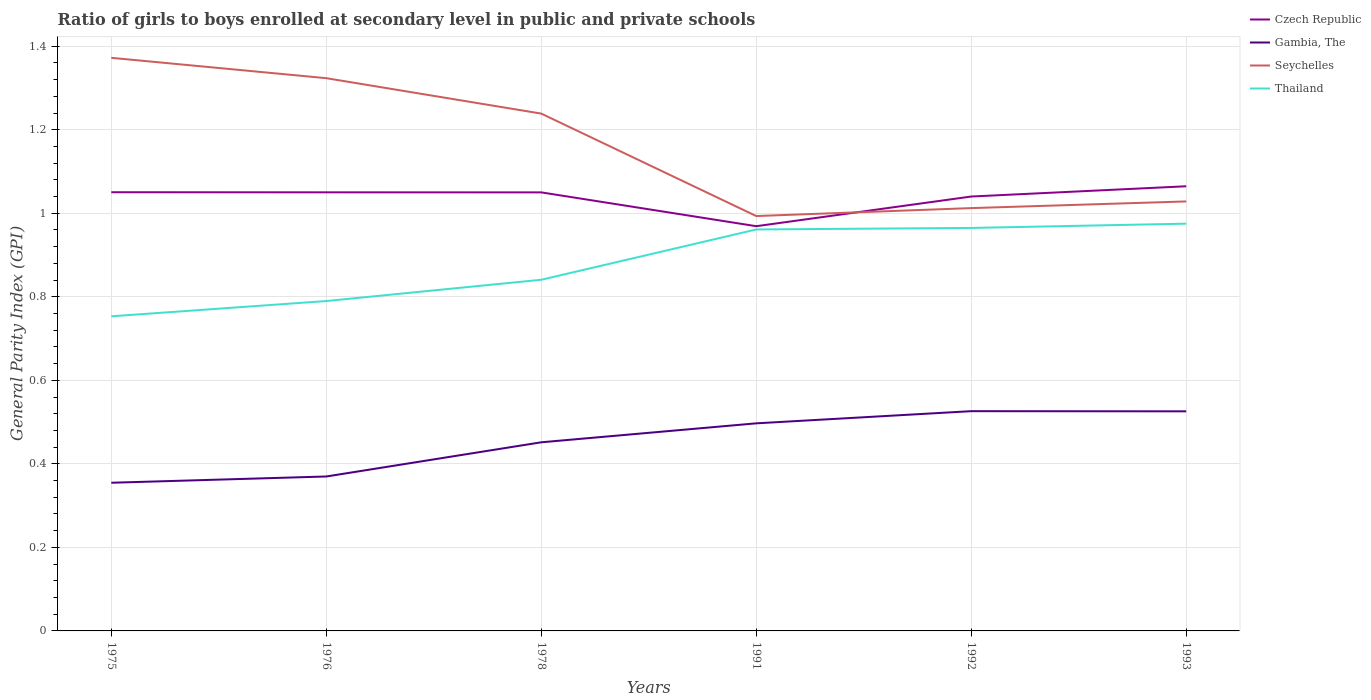How many different coloured lines are there?
Your answer should be very brief. 4. Does the line corresponding to Seychelles intersect with the line corresponding to Thailand?
Your answer should be very brief. No. Is the number of lines equal to the number of legend labels?
Your response must be concise. Yes. Across all years, what is the maximum general parity index in Czech Republic?
Make the answer very short. 0.97. What is the total general parity index in Gambia, The in the graph?
Make the answer very short. -0.1. What is the difference between the highest and the second highest general parity index in Thailand?
Offer a very short reply. 0.22. What is the difference between the highest and the lowest general parity index in Seychelles?
Provide a succinct answer. 3. Is the general parity index in Thailand strictly greater than the general parity index in Seychelles over the years?
Offer a very short reply. Yes. Where does the legend appear in the graph?
Offer a very short reply. Top right. How many legend labels are there?
Your response must be concise. 4. How are the legend labels stacked?
Your response must be concise. Vertical. What is the title of the graph?
Your answer should be very brief. Ratio of girls to boys enrolled at secondary level in public and private schools. Does "Euro area" appear as one of the legend labels in the graph?
Provide a short and direct response. No. What is the label or title of the Y-axis?
Give a very brief answer. General Parity Index (GPI). What is the General Parity Index (GPI) of Czech Republic in 1975?
Offer a very short reply. 1.05. What is the General Parity Index (GPI) in Gambia, The in 1975?
Keep it short and to the point. 0.35. What is the General Parity Index (GPI) in Seychelles in 1975?
Keep it short and to the point. 1.37. What is the General Parity Index (GPI) of Thailand in 1975?
Make the answer very short. 0.75. What is the General Parity Index (GPI) of Czech Republic in 1976?
Offer a terse response. 1.05. What is the General Parity Index (GPI) in Gambia, The in 1976?
Offer a very short reply. 0.37. What is the General Parity Index (GPI) of Seychelles in 1976?
Your answer should be very brief. 1.32. What is the General Parity Index (GPI) of Thailand in 1976?
Your answer should be very brief. 0.79. What is the General Parity Index (GPI) in Czech Republic in 1978?
Your answer should be compact. 1.05. What is the General Parity Index (GPI) of Gambia, The in 1978?
Your response must be concise. 0.45. What is the General Parity Index (GPI) in Seychelles in 1978?
Provide a succinct answer. 1.24. What is the General Parity Index (GPI) of Thailand in 1978?
Keep it short and to the point. 0.84. What is the General Parity Index (GPI) of Czech Republic in 1991?
Offer a terse response. 0.97. What is the General Parity Index (GPI) of Gambia, The in 1991?
Provide a short and direct response. 0.5. What is the General Parity Index (GPI) in Seychelles in 1991?
Offer a very short reply. 0.99. What is the General Parity Index (GPI) in Thailand in 1991?
Keep it short and to the point. 0.96. What is the General Parity Index (GPI) of Czech Republic in 1992?
Ensure brevity in your answer.  1.04. What is the General Parity Index (GPI) in Gambia, The in 1992?
Offer a very short reply. 0.53. What is the General Parity Index (GPI) of Seychelles in 1992?
Provide a short and direct response. 1.01. What is the General Parity Index (GPI) of Thailand in 1992?
Make the answer very short. 0.96. What is the General Parity Index (GPI) in Czech Republic in 1993?
Make the answer very short. 1.06. What is the General Parity Index (GPI) of Gambia, The in 1993?
Make the answer very short. 0.53. What is the General Parity Index (GPI) of Seychelles in 1993?
Provide a short and direct response. 1.03. What is the General Parity Index (GPI) of Thailand in 1993?
Provide a short and direct response. 0.98. Across all years, what is the maximum General Parity Index (GPI) of Czech Republic?
Provide a succinct answer. 1.06. Across all years, what is the maximum General Parity Index (GPI) of Gambia, The?
Provide a short and direct response. 0.53. Across all years, what is the maximum General Parity Index (GPI) of Seychelles?
Your answer should be very brief. 1.37. Across all years, what is the maximum General Parity Index (GPI) in Thailand?
Offer a very short reply. 0.98. Across all years, what is the minimum General Parity Index (GPI) of Czech Republic?
Offer a very short reply. 0.97. Across all years, what is the minimum General Parity Index (GPI) of Gambia, The?
Your response must be concise. 0.35. Across all years, what is the minimum General Parity Index (GPI) of Seychelles?
Provide a succinct answer. 0.99. Across all years, what is the minimum General Parity Index (GPI) of Thailand?
Your response must be concise. 0.75. What is the total General Parity Index (GPI) of Czech Republic in the graph?
Your answer should be compact. 6.22. What is the total General Parity Index (GPI) of Gambia, The in the graph?
Offer a very short reply. 2.73. What is the total General Parity Index (GPI) in Seychelles in the graph?
Make the answer very short. 6.97. What is the total General Parity Index (GPI) of Thailand in the graph?
Ensure brevity in your answer.  5.29. What is the difference between the General Parity Index (GPI) of Gambia, The in 1975 and that in 1976?
Offer a terse response. -0.01. What is the difference between the General Parity Index (GPI) in Seychelles in 1975 and that in 1976?
Provide a short and direct response. 0.05. What is the difference between the General Parity Index (GPI) of Thailand in 1975 and that in 1976?
Provide a succinct answer. -0.04. What is the difference between the General Parity Index (GPI) in Czech Republic in 1975 and that in 1978?
Ensure brevity in your answer.  0. What is the difference between the General Parity Index (GPI) of Gambia, The in 1975 and that in 1978?
Provide a succinct answer. -0.1. What is the difference between the General Parity Index (GPI) of Seychelles in 1975 and that in 1978?
Provide a succinct answer. 0.13. What is the difference between the General Parity Index (GPI) of Thailand in 1975 and that in 1978?
Give a very brief answer. -0.09. What is the difference between the General Parity Index (GPI) in Czech Republic in 1975 and that in 1991?
Your answer should be compact. 0.08. What is the difference between the General Parity Index (GPI) in Gambia, The in 1975 and that in 1991?
Give a very brief answer. -0.14. What is the difference between the General Parity Index (GPI) of Seychelles in 1975 and that in 1991?
Keep it short and to the point. 0.38. What is the difference between the General Parity Index (GPI) of Thailand in 1975 and that in 1991?
Your response must be concise. -0.21. What is the difference between the General Parity Index (GPI) in Czech Republic in 1975 and that in 1992?
Your answer should be compact. 0.01. What is the difference between the General Parity Index (GPI) of Gambia, The in 1975 and that in 1992?
Your answer should be very brief. -0.17. What is the difference between the General Parity Index (GPI) of Seychelles in 1975 and that in 1992?
Give a very brief answer. 0.36. What is the difference between the General Parity Index (GPI) in Thailand in 1975 and that in 1992?
Give a very brief answer. -0.21. What is the difference between the General Parity Index (GPI) in Czech Republic in 1975 and that in 1993?
Your answer should be very brief. -0.01. What is the difference between the General Parity Index (GPI) of Gambia, The in 1975 and that in 1993?
Your response must be concise. -0.17. What is the difference between the General Parity Index (GPI) of Seychelles in 1975 and that in 1993?
Keep it short and to the point. 0.34. What is the difference between the General Parity Index (GPI) of Thailand in 1975 and that in 1993?
Keep it short and to the point. -0.22. What is the difference between the General Parity Index (GPI) in Gambia, The in 1976 and that in 1978?
Provide a succinct answer. -0.08. What is the difference between the General Parity Index (GPI) in Seychelles in 1976 and that in 1978?
Make the answer very short. 0.08. What is the difference between the General Parity Index (GPI) of Thailand in 1976 and that in 1978?
Keep it short and to the point. -0.05. What is the difference between the General Parity Index (GPI) in Czech Republic in 1976 and that in 1991?
Give a very brief answer. 0.08. What is the difference between the General Parity Index (GPI) in Gambia, The in 1976 and that in 1991?
Your answer should be very brief. -0.13. What is the difference between the General Parity Index (GPI) in Seychelles in 1976 and that in 1991?
Ensure brevity in your answer.  0.33. What is the difference between the General Parity Index (GPI) in Thailand in 1976 and that in 1991?
Your answer should be compact. -0.17. What is the difference between the General Parity Index (GPI) in Czech Republic in 1976 and that in 1992?
Your answer should be compact. 0.01. What is the difference between the General Parity Index (GPI) in Gambia, The in 1976 and that in 1992?
Your response must be concise. -0.16. What is the difference between the General Parity Index (GPI) of Seychelles in 1976 and that in 1992?
Provide a succinct answer. 0.31. What is the difference between the General Parity Index (GPI) of Thailand in 1976 and that in 1992?
Provide a short and direct response. -0.17. What is the difference between the General Parity Index (GPI) in Czech Republic in 1976 and that in 1993?
Provide a succinct answer. -0.01. What is the difference between the General Parity Index (GPI) in Gambia, The in 1976 and that in 1993?
Offer a very short reply. -0.16. What is the difference between the General Parity Index (GPI) in Seychelles in 1976 and that in 1993?
Give a very brief answer. 0.3. What is the difference between the General Parity Index (GPI) in Thailand in 1976 and that in 1993?
Offer a very short reply. -0.19. What is the difference between the General Parity Index (GPI) in Czech Republic in 1978 and that in 1991?
Your answer should be compact. 0.08. What is the difference between the General Parity Index (GPI) in Gambia, The in 1978 and that in 1991?
Provide a short and direct response. -0.05. What is the difference between the General Parity Index (GPI) in Seychelles in 1978 and that in 1991?
Offer a terse response. 0.25. What is the difference between the General Parity Index (GPI) in Thailand in 1978 and that in 1991?
Offer a very short reply. -0.12. What is the difference between the General Parity Index (GPI) in Czech Republic in 1978 and that in 1992?
Offer a very short reply. 0.01. What is the difference between the General Parity Index (GPI) in Gambia, The in 1978 and that in 1992?
Offer a terse response. -0.07. What is the difference between the General Parity Index (GPI) of Seychelles in 1978 and that in 1992?
Make the answer very short. 0.23. What is the difference between the General Parity Index (GPI) in Thailand in 1978 and that in 1992?
Make the answer very short. -0.12. What is the difference between the General Parity Index (GPI) of Czech Republic in 1978 and that in 1993?
Your answer should be very brief. -0.01. What is the difference between the General Parity Index (GPI) in Gambia, The in 1978 and that in 1993?
Your answer should be very brief. -0.07. What is the difference between the General Parity Index (GPI) in Seychelles in 1978 and that in 1993?
Offer a very short reply. 0.21. What is the difference between the General Parity Index (GPI) in Thailand in 1978 and that in 1993?
Your response must be concise. -0.13. What is the difference between the General Parity Index (GPI) of Czech Republic in 1991 and that in 1992?
Your response must be concise. -0.07. What is the difference between the General Parity Index (GPI) of Gambia, The in 1991 and that in 1992?
Your answer should be very brief. -0.03. What is the difference between the General Parity Index (GPI) in Seychelles in 1991 and that in 1992?
Offer a terse response. -0.02. What is the difference between the General Parity Index (GPI) of Thailand in 1991 and that in 1992?
Give a very brief answer. -0. What is the difference between the General Parity Index (GPI) of Czech Republic in 1991 and that in 1993?
Make the answer very short. -0.1. What is the difference between the General Parity Index (GPI) of Gambia, The in 1991 and that in 1993?
Offer a very short reply. -0.03. What is the difference between the General Parity Index (GPI) in Seychelles in 1991 and that in 1993?
Offer a terse response. -0.04. What is the difference between the General Parity Index (GPI) of Thailand in 1991 and that in 1993?
Offer a terse response. -0.01. What is the difference between the General Parity Index (GPI) in Czech Republic in 1992 and that in 1993?
Your answer should be compact. -0.02. What is the difference between the General Parity Index (GPI) in Seychelles in 1992 and that in 1993?
Offer a very short reply. -0.02. What is the difference between the General Parity Index (GPI) of Thailand in 1992 and that in 1993?
Offer a terse response. -0.01. What is the difference between the General Parity Index (GPI) in Czech Republic in 1975 and the General Parity Index (GPI) in Gambia, The in 1976?
Your answer should be compact. 0.68. What is the difference between the General Parity Index (GPI) in Czech Republic in 1975 and the General Parity Index (GPI) in Seychelles in 1976?
Your answer should be compact. -0.27. What is the difference between the General Parity Index (GPI) of Czech Republic in 1975 and the General Parity Index (GPI) of Thailand in 1976?
Your answer should be compact. 0.26. What is the difference between the General Parity Index (GPI) of Gambia, The in 1975 and the General Parity Index (GPI) of Seychelles in 1976?
Make the answer very short. -0.97. What is the difference between the General Parity Index (GPI) in Gambia, The in 1975 and the General Parity Index (GPI) in Thailand in 1976?
Your answer should be compact. -0.44. What is the difference between the General Parity Index (GPI) of Seychelles in 1975 and the General Parity Index (GPI) of Thailand in 1976?
Provide a succinct answer. 0.58. What is the difference between the General Parity Index (GPI) of Czech Republic in 1975 and the General Parity Index (GPI) of Gambia, The in 1978?
Your response must be concise. 0.6. What is the difference between the General Parity Index (GPI) of Czech Republic in 1975 and the General Parity Index (GPI) of Seychelles in 1978?
Make the answer very short. -0.19. What is the difference between the General Parity Index (GPI) of Czech Republic in 1975 and the General Parity Index (GPI) of Thailand in 1978?
Provide a short and direct response. 0.21. What is the difference between the General Parity Index (GPI) of Gambia, The in 1975 and the General Parity Index (GPI) of Seychelles in 1978?
Offer a very short reply. -0.88. What is the difference between the General Parity Index (GPI) of Gambia, The in 1975 and the General Parity Index (GPI) of Thailand in 1978?
Your response must be concise. -0.49. What is the difference between the General Parity Index (GPI) in Seychelles in 1975 and the General Parity Index (GPI) in Thailand in 1978?
Offer a very short reply. 0.53. What is the difference between the General Parity Index (GPI) of Czech Republic in 1975 and the General Parity Index (GPI) of Gambia, The in 1991?
Your response must be concise. 0.55. What is the difference between the General Parity Index (GPI) of Czech Republic in 1975 and the General Parity Index (GPI) of Seychelles in 1991?
Provide a short and direct response. 0.06. What is the difference between the General Parity Index (GPI) in Czech Republic in 1975 and the General Parity Index (GPI) in Thailand in 1991?
Make the answer very short. 0.09. What is the difference between the General Parity Index (GPI) of Gambia, The in 1975 and the General Parity Index (GPI) of Seychelles in 1991?
Give a very brief answer. -0.64. What is the difference between the General Parity Index (GPI) in Gambia, The in 1975 and the General Parity Index (GPI) in Thailand in 1991?
Offer a terse response. -0.61. What is the difference between the General Parity Index (GPI) of Seychelles in 1975 and the General Parity Index (GPI) of Thailand in 1991?
Provide a short and direct response. 0.41. What is the difference between the General Parity Index (GPI) of Czech Republic in 1975 and the General Parity Index (GPI) of Gambia, The in 1992?
Keep it short and to the point. 0.52. What is the difference between the General Parity Index (GPI) in Czech Republic in 1975 and the General Parity Index (GPI) in Seychelles in 1992?
Your response must be concise. 0.04. What is the difference between the General Parity Index (GPI) of Czech Republic in 1975 and the General Parity Index (GPI) of Thailand in 1992?
Your response must be concise. 0.09. What is the difference between the General Parity Index (GPI) of Gambia, The in 1975 and the General Parity Index (GPI) of Seychelles in 1992?
Make the answer very short. -0.66. What is the difference between the General Parity Index (GPI) in Gambia, The in 1975 and the General Parity Index (GPI) in Thailand in 1992?
Provide a succinct answer. -0.61. What is the difference between the General Parity Index (GPI) in Seychelles in 1975 and the General Parity Index (GPI) in Thailand in 1992?
Your answer should be very brief. 0.41. What is the difference between the General Parity Index (GPI) in Czech Republic in 1975 and the General Parity Index (GPI) in Gambia, The in 1993?
Provide a succinct answer. 0.52. What is the difference between the General Parity Index (GPI) in Czech Republic in 1975 and the General Parity Index (GPI) in Seychelles in 1993?
Offer a very short reply. 0.02. What is the difference between the General Parity Index (GPI) of Czech Republic in 1975 and the General Parity Index (GPI) of Thailand in 1993?
Give a very brief answer. 0.08. What is the difference between the General Parity Index (GPI) in Gambia, The in 1975 and the General Parity Index (GPI) in Seychelles in 1993?
Provide a short and direct response. -0.67. What is the difference between the General Parity Index (GPI) in Gambia, The in 1975 and the General Parity Index (GPI) in Thailand in 1993?
Make the answer very short. -0.62. What is the difference between the General Parity Index (GPI) of Seychelles in 1975 and the General Parity Index (GPI) of Thailand in 1993?
Offer a terse response. 0.4. What is the difference between the General Parity Index (GPI) in Czech Republic in 1976 and the General Parity Index (GPI) in Gambia, The in 1978?
Provide a short and direct response. 0.6. What is the difference between the General Parity Index (GPI) of Czech Republic in 1976 and the General Parity Index (GPI) of Seychelles in 1978?
Offer a terse response. -0.19. What is the difference between the General Parity Index (GPI) of Czech Republic in 1976 and the General Parity Index (GPI) of Thailand in 1978?
Keep it short and to the point. 0.21. What is the difference between the General Parity Index (GPI) of Gambia, The in 1976 and the General Parity Index (GPI) of Seychelles in 1978?
Keep it short and to the point. -0.87. What is the difference between the General Parity Index (GPI) of Gambia, The in 1976 and the General Parity Index (GPI) of Thailand in 1978?
Ensure brevity in your answer.  -0.47. What is the difference between the General Parity Index (GPI) of Seychelles in 1976 and the General Parity Index (GPI) of Thailand in 1978?
Give a very brief answer. 0.48. What is the difference between the General Parity Index (GPI) of Czech Republic in 1976 and the General Parity Index (GPI) of Gambia, The in 1991?
Offer a very short reply. 0.55. What is the difference between the General Parity Index (GPI) of Czech Republic in 1976 and the General Parity Index (GPI) of Seychelles in 1991?
Your answer should be very brief. 0.06. What is the difference between the General Parity Index (GPI) in Czech Republic in 1976 and the General Parity Index (GPI) in Thailand in 1991?
Give a very brief answer. 0.09. What is the difference between the General Parity Index (GPI) in Gambia, The in 1976 and the General Parity Index (GPI) in Seychelles in 1991?
Give a very brief answer. -0.62. What is the difference between the General Parity Index (GPI) in Gambia, The in 1976 and the General Parity Index (GPI) in Thailand in 1991?
Provide a short and direct response. -0.59. What is the difference between the General Parity Index (GPI) in Seychelles in 1976 and the General Parity Index (GPI) in Thailand in 1991?
Ensure brevity in your answer.  0.36. What is the difference between the General Parity Index (GPI) in Czech Republic in 1976 and the General Parity Index (GPI) in Gambia, The in 1992?
Your answer should be very brief. 0.52. What is the difference between the General Parity Index (GPI) in Czech Republic in 1976 and the General Parity Index (GPI) in Seychelles in 1992?
Your answer should be compact. 0.04. What is the difference between the General Parity Index (GPI) of Czech Republic in 1976 and the General Parity Index (GPI) of Thailand in 1992?
Provide a short and direct response. 0.09. What is the difference between the General Parity Index (GPI) in Gambia, The in 1976 and the General Parity Index (GPI) in Seychelles in 1992?
Make the answer very short. -0.64. What is the difference between the General Parity Index (GPI) of Gambia, The in 1976 and the General Parity Index (GPI) of Thailand in 1992?
Provide a short and direct response. -0.6. What is the difference between the General Parity Index (GPI) in Seychelles in 1976 and the General Parity Index (GPI) in Thailand in 1992?
Offer a terse response. 0.36. What is the difference between the General Parity Index (GPI) of Czech Republic in 1976 and the General Parity Index (GPI) of Gambia, The in 1993?
Your response must be concise. 0.52. What is the difference between the General Parity Index (GPI) in Czech Republic in 1976 and the General Parity Index (GPI) in Seychelles in 1993?
Ensure brevity in your answer.  0.02. What is the difference between the General Parity Index (GPI) of Czech Republic in 1976 and the General Parity Index (GPI) of Thailand in 1993?
Your answer should be compact. 0.07. What is the difference between the General Parity Index (GPI) in Gambia, The in 1976 and the General Parity Index (GPI) in Seychelles in 1993?
Provide a short and direct response. -0.66. What is the difference between the General Parity Index (GPI) of Gambia, The in 1976 and the General Parity Index (GPI) of Thailand in 1993?
Your response must be concise. -0.61. What is the difference between the General Parity Index (GPI) in Seychelles in 1976 and the General Parity Index (GPI) in Thailand in 1993?
Provide a short and direct response. 0.35. What is the difference between the General Parity Index (GPI) in Czech Republic in 1978 and the General Parity Index (GPI) in Gambia, The in 1991?
Offer a very short reply. 0.55. What is the difference between the General Parity Index (GPI) in Czech Republic in 1978 and the General Parity Index (GPI) in Seychelles in 1991?
Your answer should be very brief. 0.06. What is the difference between the General Parity Index (GPI) of Czech Republic in 1978 and the General Parity Index (GPI) of Thailand in 1991?
Your answer should be very brief. 0.09. What is the difference between the General Parity Index (GPI) of Gambia, The in 1978 and the General Parity Index (GPI) of Seychelles in 1991?
Provide a short and direct response. -0.54. What is the difference between the General Parity Index (GPI) in Gambia, The in 1978 and the General Parity Index (GPI) in Thailand in 1991?
Provide a short and direct response. -0.51. What is the difference between the General Parity Index (GPI) of Seychelles in 1978 and the General Parity Index (GPI) of Thailand in 1991?
Provide a short and direct response. 0.28. What is the difference between the General Parity Index (GPI) of Czech Republic in 1978 and the General Parity Index (GPI) of Gambia, The in 1992?
Your answer should be very brief. 0.52. What is the difference between the General Parity Index (GPI) of Czech Republic in 1978 and the General Parity Index (GPI) of Seychelles in 1992?
Your response must be concise. 0.04. What is the difference between the General Parity Index (GPI) of Czech Republic in 1978 and the General Parity Index (GPI) of Thailand in 1992?
Offer a terse response. 0.09. What is the difference between the General Parity Index (GPI) in Gambia, The in 1978 and the General Parity Index (GPI) in Seychelles in 1992?
Your answer should be compact. -0.56. What is the difference between the General Parity Index (GPI) in Gambia, The in 1978 and the General Parity Index (GPI) in Thailand in 1992?
Give a very brief answer. -0.51. What is the difference between the General Parity Index (GPI) of Seychelles in 1978 and the General Parity Index (GPI) of Thailand in 1992?
Keep it short and to the point. 0.27. What is the difference between the General Parity Index (GPI) of Czech Republic in 1978 and the General Parity Index (GPI) of Gambia, The in 1993?
Ensure brevity in your answer.  0.52. What is the difference between the General Parity Index (GPI) of Czech Republic in 1978 and the General Parity Index (GPI) of Seychelles in 1993?
Keep it short and to the point. 0.02. What is the difference between the General Parity Index (GPI) of Czech Republic in 1978 and the General Parity Index (GPI) of Thailand in 1993?
Ensure brevity in your answer.  0.07. What is the difference between the General Parity Index (GPI) in Gambia, The in 1978 and the General Parity Index (GPI) in Seychelles in 1993?
Your response must be concise. -0.58. What is the difference between the General Parity Index (GPI) of Gambia, The in 1978 and the General Parity Index (GPI) of Thailand in 1993?
Provide a succinct answer. -0.52. What is the difference between the General Parity Index (GPI) in Seychelles in 1978 and the General Parity Index (GPI) in Thailand in 1993?
Offer a very short reply. 0.26. What is the difference between the General Parity Index (GPI) in Czech Republic in 1991 and the General Parity Index (GPI) in Gambia, The in 1992?
Your answer should be very brief. 0.44. What is the difference between the General Parity Index (GPI) in Czech Republic in 1991 and the General Parity Index (GPI) in Seychelles in 1992?
Keep it short and to the point. -0.04. What is the difference between the General Parity Index (GPI) in Czech Republic in 1991 and the General Parity Index (GPI) in Thailand in 1992?
Provide a short and direct response. 0. What is the difference between the General Parity Index (GPI) of Gambia, The in 1991 and the General Parity Index (GPI) of Seychelles in 1992?
Your answer should be compact. -0.52. What is the difference between the General Parity Index (GPI) of Gambia, The in 1991 and the General Parity Index (GPI) of Thailand in 1992?
Keep it short and to the point. -0.47. What is the difference between the General Parity Index (GPI) in Seychelles in 1991 and the General Parity Index (GPI) in Thailand in 1992?
Provide a succinct answer. 0.03. What is the difference between the General Parity Index (GPI) of Czech Republic in 1991 and the General Parity Index (GPI) of Gambia, The in 1993?
Your answer should be very brief. 0.44. What is the difference between the General Parity Index (GPI) of Czech Republic in 1991 and the General Parity Index (GPI) of Seychelles in 1993?
Offer a very short reply. -0.06. What is the difference between the General Parity Index (GPI) of Czech Republic in 1991 and the General Parity Index (GPI) of Thailand in 1993?
Your response must be concise. -0.01. What is the difference between the General Parity Index (GPI) of Gambia, The in 1991 and the General Parity Index (GPI) of Seychelles in 1993?
Your response must be concise. -0.53. What is the difference between the General Parity Index (GPI) in Gambia, The in 1991 and the General Parity Index (GPI) in Thailand in 1993?
Make the answer very short. -0.48. What is the difference between the General Parity Index (GPI) of Seychelles in 1991 and the General Parity Index (GPI) of Thailand in 1993?
Provide a succinct answer. 0.02. What is the difference between the General Parity Index (GPI) in Czech Republic in 1992 and the General Parity Index (GPI) in Gambia, The in 1993?
Ensure brevity in your answer.  0.51. What is the difference between the General Parity Index (GPI) in Czech Republic in 1992 and the General Parity Index (GPI) in Seychelles in 1993?
Make the answer very short. 0.01. What is the difference between the General Parity Index (GPI) of Czech Republic in 1992 and the General Parity Index (GPI) of Thailand in 1993?
Provide a short and direct response. 0.07. What is the difference between the General Parity Index (GPI) of Gambia, The in 1992 and the General Parity Index (GPI) of Seychelles in 1993?
Provide a short and direct response. -0.5. What is the difference between the General Parity Index (GPI) in Gambia, The in 1992 and the General Parity Index (GPI) in Thailand in 1993?
Offer a terse response. -0.45. What is the difference between the General Parity Index (GPI) of Seychelles in 1992 and the General Parity Index (GPI) of Thailand in 1993?
Your answer should be compact. 0.04. What is the average General Parity Index (GPI) in Czech Republic per year?
Offer a terse response. 1.04. What is the average General Parity Index (GPI) in Gambia, The per year?
Keep it short and to the point. 0.45. What is the average General Parity Index (GPI) in Seychelles per year?
Offer a terse response. 1.16. What is the average General Parity Index (GPI) in Thailand per year?
Provide a succinct answer. 0.88. In the year 1975, what is the difference between the General Parity Index (GPI) of Czech Republic and General Parity Index (GPI) of Gambia, The?
Offer a terse response. 0.7. In the year 1975, what is the difference between the General Parity Index (GPI) of Czech Republic and General Parity Index (GPI) of Seychelles?
Give a very brief answer. -0.32. In the year 1975, what is the difference between the General Parity Index (GPI) in Czech Republic and General Parity Index (GPI) in Thailand?
Your answer should be very brief. 0.3. In the year 1975, what is the difference between the General Parity Index (GPI) in Gambia, The and General Parity Index (GPI) in Seychelles?
Provide a short and direct response. -1.02. In the year 1975, what is the difference between the General Parity Index (GPI) in Gambia, The and General Parity Index (GPI) in Thailand?
Provide a succinct answer. -0.4. In the year 1975, what is the difference between the General Parity Index (GPI) of Seychelles and General Parity Index (GPI) of Thailand?
Make the answer very short. 0.62. In the year 1976, what is the difference between the General Parity Index (GPI) of Czech Republic and General Parity Index (GPI) of Gambia, The?
Ensure brevity in your answer.  0.68. In the year 1976, what is the difference between the General Parity Index (GPI) in Czech Republic and General Parity Index (GPI) in Seychelles?
Your answer should be very brief. -0.27. In the year 1976, what is the difference between the General Parity Index (GPI) of Czech Republic and General Parity Index (GPI) of Thailand?
Your answer should be very brief. 0.26. In the year 1976, what is the difference between the General Parity Index (GPI) of Gambia, The and General Parity Index (GPI) of Seychelles?
Your response must be concise. -0.95. In the year 1976, what is the difference between the General Parity Index (GPI) in Gambia, The and General Parity Index (GPI) in Thailand?
Provide a short and direct response. -0.42. In the year 1976, what is the difference between the General Parity Index (GPI) of Seychelles and General Parity Index (GPI) of Thailand?
Offer a terse response. 0.53. In the year 1978, what is the difference between the General Parity Index (GPI) in Czech Republic and General Parity Index (GPI) in Gambia, The?
Provide a succinct answer. 0.6. In the year 1978, what is the difference between the General Parity Index (GPI) in Czech Republic and General Parity Index (GPI) in Seychelles?
Offer a very short reply. -0.19. In the year 1978, what is the difference between the General Parity Index (GPI) in Czech Republic and General Parity Index (GPI) in Thailand?
Provide a short and direct response. 0.21. In the year 1978, what is the difference between the General Parity Index (GPI) in Gambia, The and General Parity Index (GPI) in Seychelles?
Provide a succinct answer. -0.79. In the year 1978, what is the difference between the General Parity Index (GPI) of Gambia, The and General Parity Index (GPI) of Thailand?
Your answer should be compact. -0.39. In the year 1978, what is the difference between the General Parity Index (GPI) in Seychelles and General Parity Index (GPI) in Thailand?
Offer a terse response. 0.4. In the year 1991, what is the difference between the General Parity Index (GPI) in Czech Republic and General Parity Index (GPI) in Gambia, The?
Give a very brief answer. 0.47. In the year 1991, what is the difference between the General Parity Index (GPI) of Czech Republic and General Parity Index (GPI) of Seychelles?
Make the answer very short. -0.02. In the year 1991, what is the difference between the General Parity Index (GPI) of Czech Republic and General Parity Index (GPI) of Thailand?
Offer a terse response. 0.01. In the year 1991, what is the difference between the General Parity Index (GPI) in Gambia, The and General Parity Index (GPI) in Seychelles?
Keep it short and to the point. -0.5. In the year 1991, what is the difference between the General Parity Index (GPI) in Gambia, The and General Parity Index (GPI) in Thailand?
Your response must be concise. -0.46. In the year 1991, what is the difference between the General Parity Index (GPI) in Seychelles and General Parity Index (GPI) in Thailand?
Give a very brief answer. 0.03. In the year 1992, what is the difference between the General Parity Index (GPI) in Czech Republic and General Parity Index (GPI) in Gambia, The?
Offer a very short reply. 0.51. In the year 1992, what is the difference between the General Parity Index (GPI) of Czech Republic and General Parity Index (GPI) of Seychelles?
Keep it short and to the point. 0.03. In the year 1992, what is the difference between the General Parity Index (GPI) in Czech Republic and General Parity Index (GPI) in Thailand?
Give a very brief answer. 0.08. In the year 1992, what is the difference between the General Parity Index (GPI) in Gambia, The and General Parity Index (GPI) in Seychelles?
Give a very brief answer. -0.49. In the year 1992, what is the difference between the General Parity Index (GPI) of Gambia, The and General Parity Index (GPI) of Thailand?
Provide a succinct answer. -0.44. In the year 1992, what is the difference between the General Parity Index (GPI) of Seychelles and General Parity Index (GPI) of Thailand?
Offer a terse response. 0.05. In the year 1993, what is the difference between the General Parity Index (GPI) in Czech Republic and General Parity Index (GPI) in Gambia, The?
Your answer should be compact. 0.54. In the year 1993, what is the difference between the General Parity Index (GPI) in Czech Republic and General Parity Index (GPI) in Seychelles?
Provide a short and direct response. 0.04. In the year 1993, what is the difference between the General Parity Index (GPI) of Czech Republic and General Parity Index (GPI) of Thailand?
Ensure brevity in your answer.  0.09. In the year 1993, what is the difference between the General Parity Index (GPI) of Gambia, The and General Parity Index (GPI) of Seychelles?
Offer a very short reply. -0.5. In the year 1993, what is the difference between the General Parity Index (GPI) of Gambia, The and General Parity Index (GPI) of Thailand?
Provide a short and direct response. -0.45. In the year 1993, what is the difference between the General Parity Index (GPI) of Seychelles and General Parity Index (GPI) of Thailand?
Offer a very short reply. 0.05. What is the ratio of the General Parity Index (GPI) of Czech Republic in 1975 to that in 1976?
Your answer should be very brief. 1. What is the ratio of the General Parity Index (GPI) in Gambia, The in 1975 to that in 1976?
Your answer should be compact. 0.96. What is the ratio of the General Parity Index (GPI) of Seychelles in 1975 to that in 1976?
Provide a succinct answer. 1.04. What is the ratio of the General Parity Index (GPI) in Thailand in 1975 to that in 1976?
Make the answer very short. 0.95. What is the ratio of the General Parity Index (GPI) in Gambia, The in 1975 to that in 1978?
Your answer should be compact. 0.79. What is the ratio of the General Parity Index (GPI) of Seychelles in 1975 to that in 1978?
Make the answer very short. 1.11. What is the ratio of the General Parity Index (GPI) of Thailand in 1975 to that in 1978?
Your answer should be compact. 0.9. What is the ratio of the General Parity Index (GPI) of Czech Republic in 1975 to that in 1991?
Ensure brevity in your answer.  1.08. What is the ratio of the General Parity Index (GPI) in Gambia, The in 1975 to that in 1991?
Your answer should be very brief. 0.71. What is the ratio of the General Parity Index (GPI) of Seychelles in 1975 to that in 1991?
Your answer should be compact. 1.38. What is the ratio of the General Parity Index (GPI) in Thailand in 1975 to that in 1991?
Make the answer very short. 0.78. What is the ratio of the General Parity Index (GPI) of Czech Republic in 1975 to that in 1992?
Offer a terse response. 1.01. What is the ratio of the General Parity Index (GPI) in Gambia, The in 1975 to that in 1992?
Your answer should be very brief. 0.67. What is the ratio of the General Parity Index (GPI) in Seychelles in 1975 to that in 1992?
Offer a very short reply. 1.36. What is the ratio of the General Parity Index (GPI) in Thailand in 1975 to that in 1992?
Your answer should be compact. 0.78. What is the ratio of the General Parity Index (GPI) of Czech Republic in 1975 to that in 1993?
Provide a short and direct response. 0.99. What is the ratio of the General Parity Index (GPI) of Gambia, The in 1975 to that in 1993?
Your response must be concise. 0.67. What is the ratio of the General Parity Index (GPI) in Seychelles in 1975 to that in 1993?
Provide a short and direct response. 1.33. What is the ratio of the General Parity Index (GPI) in Thailand in 1975 to that in 1993?
Ensure brevity in your answer.  0.77. What is the ratio of the General Parity Index (GPI) of Czech Republic in 1976 to that in 1978?
Offer a terse response. 1. What is the ratio of the General Parity Index (GPI) of Gambia, The in 1976 to that in 1978?
Your response must be concise. 0.82. What is the ratio of the General Parity Index (GPI) of Seychelles in 1976 to that in 1978?
Offer a very short reply. 1.07. What is the ratio of the General Parity Index (GPI) of Thailand in 1976 to that in 1978?
Your answer should be very brief. 0.94. What is the ratio of the General Parity Index (GPI) of Czech Republic in 1976 to that in 1991?
Keep it short and to the point. 1.08. What is the ratio of the General Parity Index (GPI) in Gambia, The in 1976 to that in 1991?
Your response must be concise. 0.74. What is the ratio of the General Parity Index (GPI) of Seychelles in 1976 to that in 1991?
Your answer should be compact. 1.33. What is the ratio of the General Parity Index (GPI) of Thailand in 1976 to that in 1991?
Provide a succinct answer. 0.82. What is the ratio of the General Parity Index (GPI) of Czech Republic in 1976 to that in 1992?
Provide a succinct answer. 1.01. What is the ratio of the General Parity Index (GPI) of Gambia, The in 1976 to that in 1992?
Your answer should be very brief. 0.7. What is the ratio of the General Parity Index (GPI) of Seychelles in 1976 to that in 1992?
Make the answer very short. 1.31. What is the ratio of the General Parity Index (GPI) of Thailand in 1976 to that in 1992?
Your answer should be compact. 0.82. What is the ratio of the General Parity Index (GPI) of Czech Republic in 1976 to that in 1993?
Offer a very short reply. 0.99. What is the ratio of the General Parity Index (GPI) of Gambia, The in 1976 to that in 1993?
Your answer should be compact. 0.7. What is the ratio of the General Parity Index (GPI) of Seychelles in 1976 to that in 1993?
Keep it short and to the point. 1.29. What is the ratio of the General Parity Index (GPI) of Thailand in 1976 to that in 1993?
Make the answer very short. 0.81. What is the ratio of the General Parity Index (GPI) of Czech Republic in 1978 to that in 1991?
Make the answer very short. 1.08. What is the ratio of the General Parity Index (GPI) of Gambia, The in 1978 to that in 1991?
Your answer should be compact. 0.91. What is the ratio of the General Parity Index (GPI) in Seychelles in 1978 to that in 1991?
Ensure brevity in your answer.  1.25. What is the ratio of the General Parity Index (GPI) of Thailand in 1978 to that in 1991?
Provide a short and direct response. 0.87. What is the ratio of the General Parity Index (GPI) of Czech Republic in 1978 to that in 1992?
Make the answer very short. 1.01. What is the ratio of the General Parity Index (GPI) in Gambia, The in 1978 to that in 1992?
Your response must be concise. 0.86. What is the ratio of the General Parity Index (GPI) of Seychelles in 1978 to that in 1992?
Give a very brief answer. 1.22. What is the ratio of the General Parity Index (GPI) of Thailand in 1978 to that in 1992?
Offer a terse response. 0.87. What is the ratio of the General Parity Index (GPI) of Czech Republic in 1978 to that in 1993?
Your answer should be very brief. 0.99. What is the ratio of the General Parity Index (GPI) in Gambia, The in 1978 to that in 1993?
Offer a very short reply. 0.86. What is the ratio of the General Parity Index (GPI) in Seychelles in 1978 to that in 1993?
Your answer should be compact. 1.2. What is the ratio of the General Parity Index (GPI) in Thailand in 1978 to that in 1993?
Provide a short and direct response. 0.86. What is the ratio of the General Parity Index (GPI) of Czech Republic in 1991 to that in 1992?
Keep it short and to the point. 0.93. What is the ratio of the General Parity Index (GPI) in Gambia, The in 1991 to that in 1992?
Your answer should be very brief. 0.94. What is the ratio of the General Parity Index (GPI) of Seychelles in 1991 to that in 1992?
Provide a succinct answer. 0.98. What is the ratio of the General Parity Index (GPI) of Czech Republic in 1991 to that in 1993?
Make the answer very short. 0.91. What is the ratio of the General Parity Index (GPI) of Gambia, The in 1991 to that in 1993?
Your answer should be compact. 0.95. What is the ratio of the General Parity Index (GPI) of Thailand in 1991 to that in 1993?
Make the answer very short. 0.99. What is the ratio of the General Parity Index (GPI) in Czech Republic in 1992 to that in 1993?
Make the answer very short. 0.98. What is the ratio of the General Parity Index (GPI) in Gambia, The in 1992 to that in 1993?
Provide a short and direct response. 1. What is the ratio of the General Parity Index (GPI) of Seychelles in 1992 to that in 1993?
Provide a succinct answer. 0.98. What is the ratio of the General Parity Index (GPI) in Thailand in 1992 to that in 1993?
Provide a short and direct response. 0.99. What is the difference between the highest and the second highest General Parity Index (GPI) in Czech Republic?
Provide a short and direct response. 0.01. What is the difference between the highest and the second highest General Parity Index (GPI) of Seychelles?
Provide a short and direct response. 0.05. What is the difference between the highest and the second highest General Parity Index (GPI) of Thailand?
Offer a terse response. 0.01. What is the difference between the highest and the lowest General Parity Index (GPI) in Czech Republic?
Your answer should be very brief. 0.1. What is the difference between the highest and the lowest General Parity Index (GPI) in Gambia, The?
Give a very brief answer. 0.17. What is the difference between the highest and the lowest General Parity Index (GPI) of Seychelles?
Ensure brevity in your answer.  0.38. What is the difference between the highest and the lowest General Parity Index (GPI) in Thailand?
Provide a short and direct response. 0.22. 